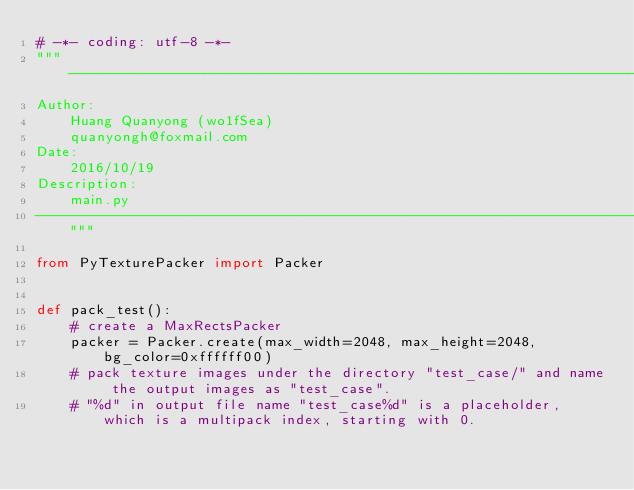Convert code to text. <code><loc_0><loc_0><loc_500><loc_500><_Python_># -*- coding: utf-8 -*-
"""----------------------------------------------------------------------------
Author:
    Huang Quanyong (wo1fSea)
    quanyongh@foxmail.com
Date:
    2016/10/19
Description:
    main.py
----------------------------------------------------------------------------"""

from PyTexturePacker import Packer


def pack_test():
    # create a MaxRectsPacker
    packer = Packer.create(max_width=2048, max_height=2048, bg_color=0xffffff00)
    # pack texture images under the directory "test_case/" and name the output images as "test_case".
    # "%d" in output file name "test_case%d" is a placeholder, which is a multipack index, starting with 0.</code> 